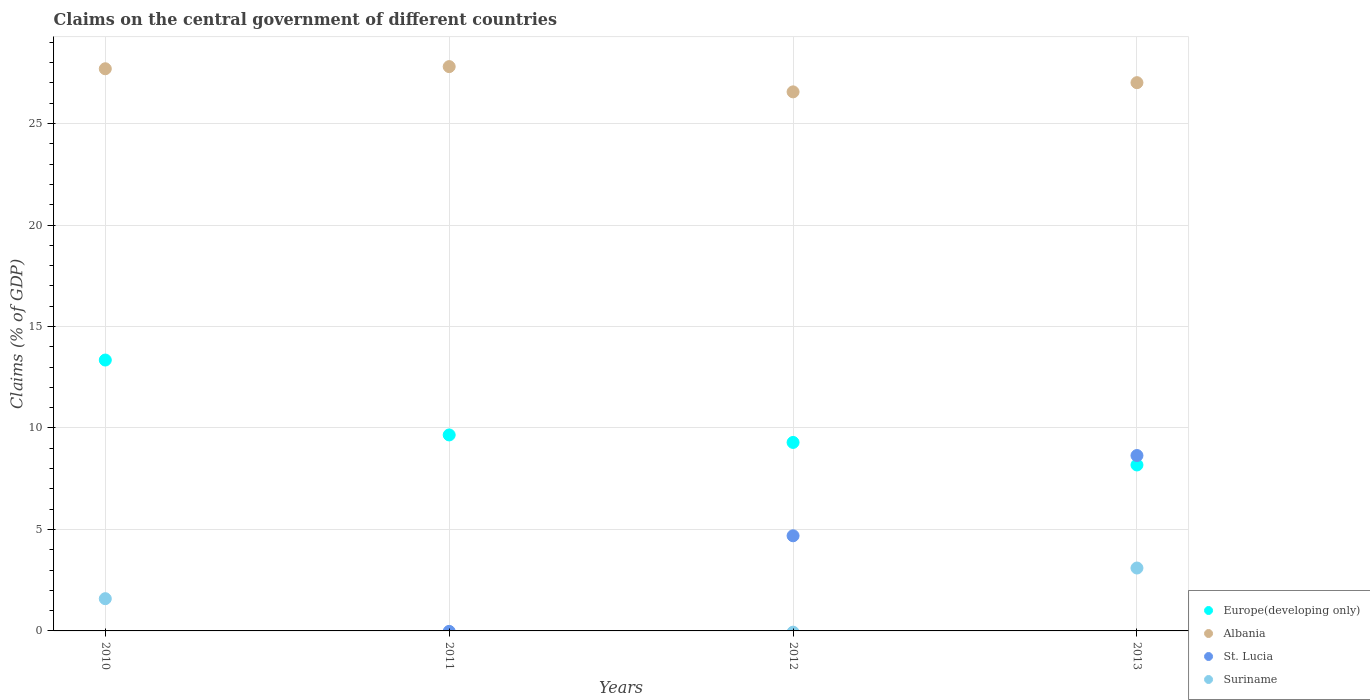What is the percentage of GDP claimed on the central government in Europe(developing only) in 2010?
Offer a very short reply. 13.35. Across all years, what is the maximum percentage of GDP claimed on the central government in Suriname?
Offer a terse response. 3.1. Across all years, what is the minimum percentage of GDP claimed on the central government in Albania?
Your response must be concise. 26.56. In which year was the percentage of GDP claimed on the central government in Albania maximum?
Provide a succinct answer. 2011. What is the total percentage of GDP claimed on the central government in Europe(developing only) in the graph?
Your answer should be very brief. 40.47. What is the difference between the percentage of GDP claimed on the central government in Albania in 2012 and that in 2013?
Give a very brief answer. -0.45. What is the difference between the percentage of GDP claimed on the central government in Suriname in 2013 and the percentage of GDP claimed on the central government in Albania in 2012?
Make the answer very short. -23.46. What is the average percentage of GDP claimed on the central government in Europe(developing only) per year?
Offer a terse response. 10.12. In the year 2013, what is the difference between the percentage of GDP claimed on the central government in Albania and percentage of GDP claimed on the central government in St. Lucia?
Offer a very short reply. 18.37. What is the ratio of the percentage of GDP claimed on the central government in St. Lucia in 2012 to that in 2013?
Provide a short and direct response. 0.54. Is the percentage of GDP claimed on the central government in St. Lucia in 2012 less than that in 2013?
Offer a terse response. Yes. Is the difference between the percentage of GDP claimed on the central government in Albania in 2012 and 2013 greater than the difference between the percentage of GDP claimed on the central government in St. Lucia in 2012 and 2013?
Offer a terse response. Yes. What is the difference between the highest and the second highest percentage of GDP claimed on the central government in Albania?
Your answer should be very brief. 0.11. What is the difference between the highest and the lowest percentage of GDP claimed on the central government in St. Lucia?
Offer a very short reply. 8.64. In how many years, is the percentage of GDP claimed on the central government in Europe(developing only) greater than the average percentage of GDP claimed on the central government in Europe(developing only) taken over all years?
Your response must be concise. 1. Is the sum of the percentage of GDP claimed on the central government in Europe(developing only) in 2011 and 2013 greater than the maximum percentage of GDP claimed on the central government in St. Lucia across all years?
Provide a succinct answer. Yes. Is it the case that in every year, the sum of the percentage of GDP claimed on the central government in St. Lucia and percentage of GDP claimed on the central government in Albania  is greater than the sum of percentage of GDP claimed on the central government in Suriname and percentage of GDP claimed on the central government in Europe(developing only)?
Provide a short and direct response. Yes. Does the percentage of GDP claimed on the central government in Europe(developing only) monotonically increase over the years?
Make the answer very short. No. Is the percentage of GDP claimed on the central government in St. Lucia strictly less than the percentage of GDP claimed on the central government in Europe(developing only) over the years?
Your answer should be very brief. No. How many dotlines are there?
Ensure brevity in your answer.  4. How many years are there in the graph?
Your answer should be compact. 4. What is the difference between two consecutive major ticks on the Y-axis?
Offer a terse response. 5. Are the values on the major ticks of Y-axis written in scientific E-notation?
Keep it short and to the point. No. Does the graph contain grids?
Offer a very short reply. Yes. How are the legend labels stacked?
Keep it short and to the point. Vertical. What is the title of the graph?
Offer a terse response. Claims on the central government of different countries. Does "Euro area" appear as one of the legend labels in the graph?
Your answer should be very brief. No. What is the label or title of the Y-axis?
Offer a terse response. Claims (% of GDP). What is the Claims (% of GDP) in Europe(developing only) in 2010?
Offer a terse response. 13.35. What is the Claims (% of GDP) of Albania in 2010?
Give a very brief answer. 27.7. What is the Claims (% of GDP) of St. Lucia in 2010?
Ensure brevity in your answer.  0. What is the Claims (% of GDP) of Suriname in 2010?
Offer a terse response. 1.59. What is the Claims (% of GDP) in Europe(developing only) in 2011?
Provide a succinct answer. 9.66. What is the Claims (% of GDP) of Albania in 2011?
Provide a short and direct response. 27.81. What is the Claims (% of GDP) in St. Lucia in 2011?
Ensure brevity in your answer.  0. What is the Claims (% of GDP) in Europe(developing only) in 2012?
Offer a terse response. 9.29. What is the Claims (% of GDP) in Albania in 2012?
Give a very brief answer. 26.56. What is the Claims (% of GDP) in St. Lucia in 2012?
Your response must be concise. 4.69. What is the Claims (% of GDP) in Suriname in 2012?
Provide a succinct answer. 0. What is the Claims (% of GDP) of Europe(developing only) in 2013?
Your answer should be very brief. 8.18. What is the Claims (% of GDP) of Albania in 2013?
Provide a short and direct response. 27.02. What is the Claims (% of GDP) of St. Lucia in 2013?
Keep it short and to the point. 8.64. What is the Claims (% of GDP) in Suriname in 2013?
Provide a succinct answer. 3.1. Across all years, what is the maximum Claims (% of GDP) in Europe(developing only)?
Keep it short and to the point. 13.35. Across all years, what is the maximum Claims (% of GDP) of Albania?
Offer a very short reply. 27.81. Across all years, what is the maximum Claims (% of GDP) in St. Lucia?
Provide a succinct answer. 8.64. Across all years, what is the maximum Claims (% of GDP) of Suriname?
Provide a succinct answer. 3.1. Across all years, what is the minimum Claims (% of GDP) of Europe(developing only)?
Provide a short and direct response. 8.18. Across all years, what is the minimum Claims (% of GDP) of Albania?
Provide a short and direct response. 26.56. Across all years, what is the minimum Claims (% of GDP) of St. Lucia?
Ensure brevity in your answer.  0. What is the total Claims (% of GDP) in Europe(developing only) in the graph?
Make the answer very short. 40.47. What is the total Claims (% of GDP) of Albania in the graph?
Provide a succinct answer. 109.09. What is the total Claims (% of GDP) in St. Lucia in the graph?
Give a very brief answer. 13.33. What is the total Claims (% of GDP) of Suriname in the graph?
Your answer should be very brief. 4.69. What is the difference between the Claims (% of GDP) in Europe(developing only) in 2010 and that in 2011?
Your answer should be very brief. 3.69. What is the difference between the Claims (% of GDP) of Albania in 2010 and that in 2011?
Provide a succinct answer. -0.11. What is the difference between the Claims (% of GDP) in Europe(developing only) in 2010 and that in 2012?
Provide a short and direct response. 4.06. What is the difference between the Claims (% of GDP) of Albania in 2010 and that in 2012?
Your answer should be compact. 1.14. What is the difference between the Claims (% of GDP) in Europe(developing only) in 2010 and that in 2013?
Your response must be concise. 5.17. What is the difference between the Claims (% of GDP) in Albania in 2010 and that in 2013?
Make the answer very short. 0.69. What is the difference between the Claims (% of GDP) in Suriname in 2010 and that in 2013?
Offer a terse response. -1.51. What is the difference between the Claims (% of GDP) of Europe(developing only) in 2011 and that in 2012?
Your answer should be very brief. 0.37. What is the difference between the Claims (% of GDP) of Albania in 2011 and that in 2012?
Ensure brevity in your answer.  1.24. What is the difference between the Claims (% of GDP) of Europe(developing only) in 2011 and that in 2013?
Offer a very short reply. 1.48. What is the difference between the Claims (% of GDP) of Albania in 2011 and that in 2013?
Give a very brief answer. 0.79. What is the difference between the Claims (% of GDP) in Europe(developing only) in 2012 and that in 2013?
Offer a terse response. 1.11. What is the difference between the Claims (% of GDP) in Albania in 2012 and that in 2013?
Provide a succinct answer. -0.45. What is the difference between the Claims (% of GDP) in St. Lucia in 2012 and that in 2013?
Ensure brevity in your answer.  -3.95. What is the difference between the Claims (% of GDP) of Europe(developing only) in 2010 and the Claims (% of GDP) of Albania in 2011?
Make the answer very short. -14.46. What is the difference between the Claims (% of GDP) of Europe(developing only) in 2010 and the Claims (% of GDP) of Albania in 2012?
Your response must be concise. -13.21. What is the difference between the Claims (% of GDP) of Europe(developing only) in 2010 and the Claims (% of GDP) of St. Lucia in 2012?
Your response must be concise. 8.66. What is the difference between the Claims (% of GDP) in Albania in 2010 and the Claims (% of GDP) in St. Lucia in 2012?
Make the answer very short. 23.01. What is the difference between the Claims (% of GDP) of Europe(developing only) in 2010 and the Claims (% of GDP) of Albania in 2013?
Provide a succinct answer. -13.67. What is the difference between the Claims (% of GDP) in Europe(developing only) in 2010 and the Claims (% of GDP) in St. Lucia in 2013?
Give a very brief answer. 4.71. What is the difference between the Claims (% of GDP) in Europe(developing only) in 2010 and the Claims (% of GDP) in Suriname in 2013?
Ensure brevity in your answer.  10.25. What is the difference between the Claims (% of GDP) in Albania in 2010 and the Claims (% of GDP) in St. Lucia in 2013?
Your answer should be compact. 19.06. What is the difference between the Claims (% of GDP) in Albania in 2010 and the Claims (% of GDP) in Suriname in 2013?
Your response must be concise. 24.6. What is the difference between the Claims (% of GDP) of Europe(developing only) in 2011 and the Claims (% of GDP) of Albania in 2012?
Provide a succinct answer. -16.9. What is the difference between the Claims (% of GDP) in Europe(developing only) in 2011 and the Claims (% of GDP) in St. Lucia in 2012?
Provide a succinct answer. 4.97. What is the difference between the Claims (% of GDP) in Albania in 2011 and the Claims (% of GDP) in St. Lucia in 2012?
Offer a terse response. 23.12. What is the difference between the Claims (% of GDP) of Europe(developing only) in 2011 and the Claims (% of GDP) of Albania in 2013?
Give a very brief answer. -17.36. What is the difference between the Claims (% of GDP) in Europe(developing only) in 2011 and the Claims (% of GDP) in St. Lucia in 2013?
Offer a very short reply. 1.01. What is the difference between the Claims (% of GDP) of Europe(developing only) in 2011 and the Claims (% of GDP) of Suriname in 2013?
Offer a terse response. 6.56. What is the difference between the Claims (% of GDP) of Albania in 2011 and the Claims (% of GDP) of St. Lucia in 2013?
Offer a terse response. 19.16. What is the difference between the Claims (% of GDP) of Albania in 2011 and the Claims (% of GDP) of Suriname in 2013?
Provide a short and direct response. 24.71. What is the difference between the Claims (% of GDP) of Europe(developing only) in 2012 and the Claims (% of GDP) of Albania in 2013?
Give a very brief answer. -17.73. What is the difference between the Claims (% of GDP) in Europe(developing only) in 2012 and the Claims (% of GDP) in St. Lucia in 2013?
Offer a terse response. 0.65. What is the difference between the Claims (% of GDP) of Europe(developing only) in 2012 and the Claims (% of GDP) of Suriname in 2013?
Provide a short and direct response. 6.19. What is the difference between the Claims (% of GDP) in Albania in 2012 and the Claims (% of GDP) in St. Lucia in 2013?
Give a very brief answer. 17.92. What is the difference between the Claims (% of GDP) of Albania in 2012 and the Claims (% of GDP) of Suriname in 2013?
Keep it short and to the point. 23.46. What is the difference between the Claims (% of GDP) of St. Lucia in 2012 and the Claims (% of GDP) of Suriname in 2013?
Your response must be concise. 1.59. What is the average Claims (% of GDP) in Europe(developing only) per year?
Give a very brief answer. 10.12. What is the average Claims (% of GDP) of Albania per year?
Offer a very short reply. 27.27. What is the average Claims (% of GDP) of St. Lucia per year?
Your answer should be compact. 3.33. What is the average Claims (% of GDP) of Suriname per year?
Give a very brief answer. 1.17. In the year 2010, what is the difference between the Claims (% of GDP) in Europe(developing only) and Claims (% of GDP) in Albania?
Ensure brevity in your answer.  -14.35. In the year 2010, what is the difference between the Claims (% of GDP) of Europe(developing only) and Claims (% of GDP) of Suriname?
Ensure brevity in your answer.  11.76. In the year 2010, what is the difference between the Claims (% of GDP) in Albania and Claims (% of GDP) in Suriname?
Your response must be concise. 26.11. In the year 2011, what is the difference between the Claims (% of GDP) of Europe(developing only) and Claims (% of GDP) of Albania?
Your answer should be very brief. -18.15. In the year 2012, what is the difference between the Claims (% of GDP) in Europe(developing only) and Claims (% of GDP) in Albania?
Provide a succinct answer. -17.27. In the year 2012, what is the difference between the Claims (% of GDP) of Europe(developing only) and Claims (% of GDP) of St. Lucia?
Offer a very short reply. 4.6. In the year 2012, what is the difference between the Claims (% of GDP) in Albania and Claims (% of GDP) in St. Lucia?
Make the answer very short. 21.87. In the year 2013, what is the difference between the Claims (% of GDP) in Europe(developing only) and Claims (% of GDP) in Albania?
Your response must be concise. -18.84. In the year 2013, what is the difference between the Claims (% of GDP) of Europe(developing only) and Claims (% of GDP) of St. Lucia?
Offer a very short reply. -0.46. In the year 2013, what is the difference between the Claims (% of GDP) of Europe(developing only) and Claims (% of GDP) of Suriname?
Give a very brief answer. 5.08. In the year 2013, what is the difference between the Claims (% of GDP) of Albania and Claims (% of GDP) of St. Lucia?
Provide a succinct answer. 18.37. In the year 2013, what is the difference between the Claims (% of GDP) of Albania and Claims (% of GDP) of Suriname?
Your answer should be very brief. 23.92. In the year 2013, what is the difference between the Claims (% of GDP) in St. Lucia and Claims (% of GDP) in Suriname?
Your answer should be compact. 5.54. What is the ratio of the Claims (% of GDP) of Europe(developing only) in 2010 to that in 2011?
Your answer should be very brief. 1.38. What is the ratio of the Claims (% of GDP) in Albania in 2010 to that in 2011?
Offer a very short reply. 1. What is the ratio of the Claims (% of GDP) of Europe(developing only) in 2010 to that in 2012?
Offer a very short reply. 1.44. What is the ratio of the Claims (% of GDP) of Albania in 2010 to that in 2012?
Make the answer very short. 1.04. What is the ratio of the Claims (% of GDP) of Europe(developing only) in 2010 to that in 2013?
Give a very brief answer. 1.63. What is the ratio of the Claims (% of GDP) in Albania in 2010 to that in 2013?
Give a very brief answer. 1.03. What is the ratio of the Claims (% of GDP) in Suriname in 2010 to that in 2013?
Your response must be concise. 0.51. What is the ratio of the Claims (% of GDP) of Europe(developing only) in 2011 to that in 2012?
Your response must be concise. 1.04. What is the ratio of the Claims (% of GDP) of Albania in 2011 to that in 2012?
Keep it short and to the point. 1.05. What is the ratio of the Claims (% of GDP) in Europe(developing only) in 2011 to that in 2013?
Provide a short and direct response. 1.18. What is the ratio of the Claims (% of GDP) of Albania in 2011 to that in 2013?
Provide a succinct answer. 1.03. What is the ratio of the Claims (% of GDP) in Europe(developing only) in 2012 to that in 2013?
Give a very brief answer. 1.14. What is the ratio of the Claims (% of GDP) in Albania in 2012 to that in 2013?
Give a very brief answer. 0.98. What is the ratio of the Claims (% of GDP) of St. Lucia in 2012 to that in 2013?
Make the answer very short. 0.54. What is the difference between the highest and the second highest Claims (% of GDP) of Europe(developing only)?
Give a very brief answer. 3.69. What is the difference between the highest and the second highest Claims (% of GDP) in Albania?
Offer a terse response. 0.11. What is the difference between the highest and the lowest Claims (% of GDP) in Europe(developing only)?
Your answer should be very brief. 5.17. What is the difference between the highest and the lowest Claims (% of GDP) of Albania?
Provide a short and direct response. 1.24. What is the difference between the highest and the lowest Claims (% of GDP) in St. Lucia?
Make the answer very short. 8.64. What is the difference between the highest and the lowest Claims (% of GDP) of Suriname?
Give a very brief answer. 3.1. 